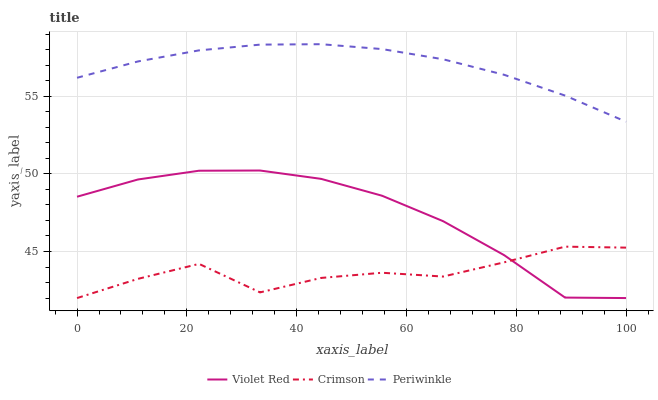Does Crimson have the minimum area under the curve?
Answer yes or no. Yes. Does Periwinkle have the maximum area under the curve?
Answer yes or no. Yes. Does Violet Red have the minimum area under the curve?
Answer yes or no. No. Does Violet Red have the maximum area under the curve?
Answer yes or no. No. Is Periwinkle the smoothest?
Answer yes or no. Yes. Is Crimson the roughest?
Answer yes or no. Yes. Is Violet Red the smoothest?
Answer yes or no. No. Is Violet Red the roughest?
Answer yes or no. No. Does Crimson have the lowest value?
Answer yes or no. Yes. Does Periwinkle have the lowest value?
Answer yes or no. No. Does Periwinkle have the highest value?
Answer yes or no. Yes. Does Violet Red have the highest value?
Answer yes or no. No. Is Crimson less than Periwinkle?
Answer yes or no. Yes. Is Periwinkle greater than Crimson?
Answer yes or no. Yes. Does Violet Red intersect Crimson?
Answer yes or no. Yes. Is Violet Red less than Crimson?
Answer yes or no. No. Is Violet Red greater than Crimson?
Answer yes or no. No. Does Crimson intersect Periwinkle?
Answer yes or no. No. 